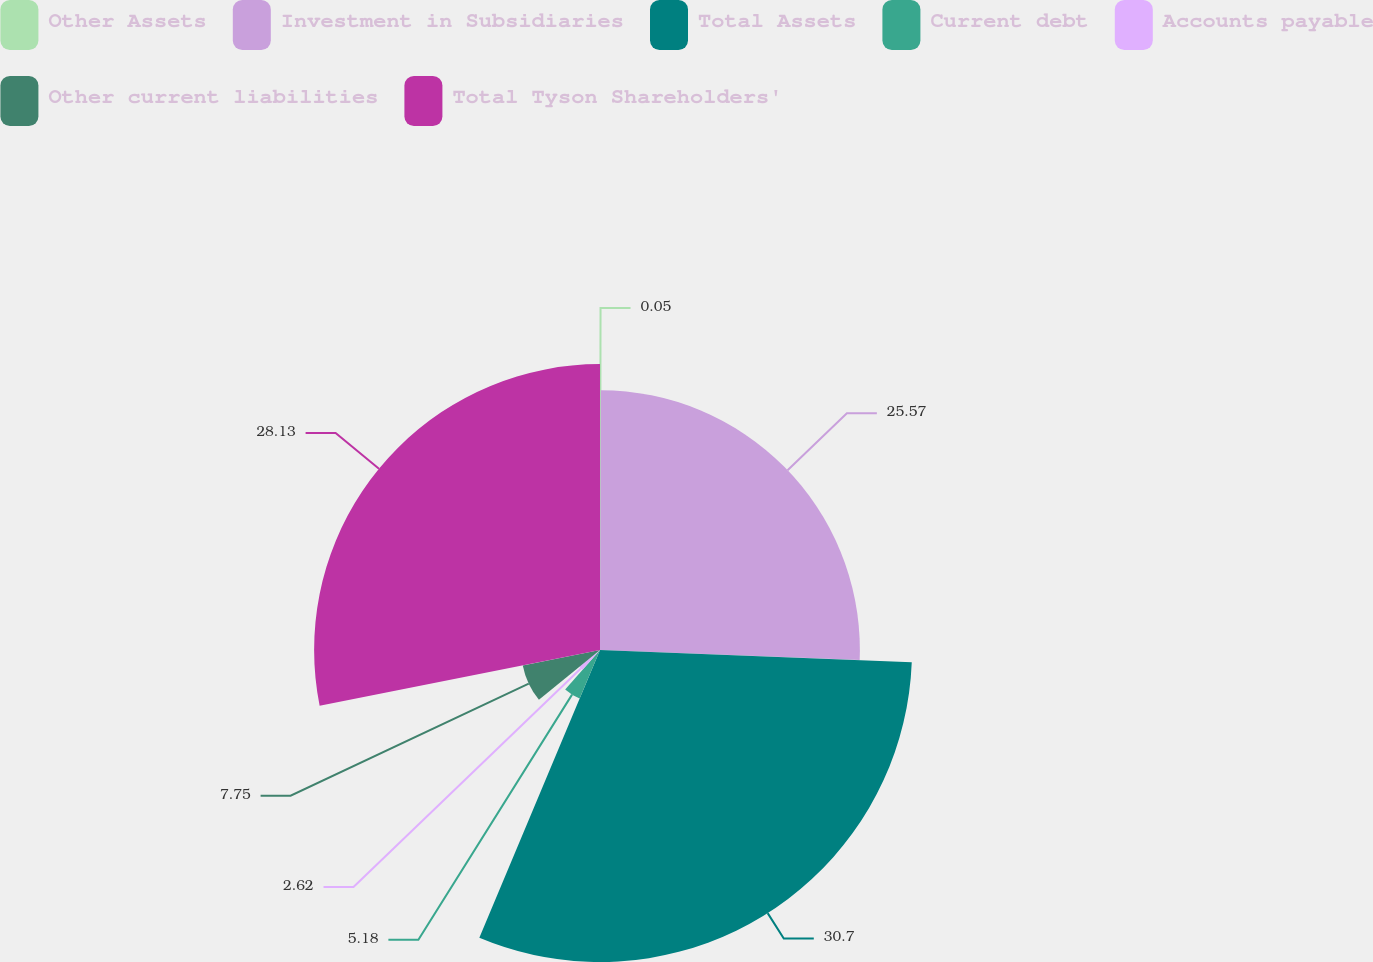Convert chart. <chart><loc_0><loc_0><loc_500><loc_500><pie_chart><fcel>Other Assets<fcel>Investment in Subsidiaries<fcel>Total Assets<fcel>Current debt<fcel>Accounts payable<fcel>Other current liabilities<fcel>Total Tyson Shareholders'<nl><fcel>0.05%<fcel>25.57%<fcel>30.7%<fcel>5.18%<fcel>2.62%<fcel>7.75%<fcel>28.13%<nl></chart> 